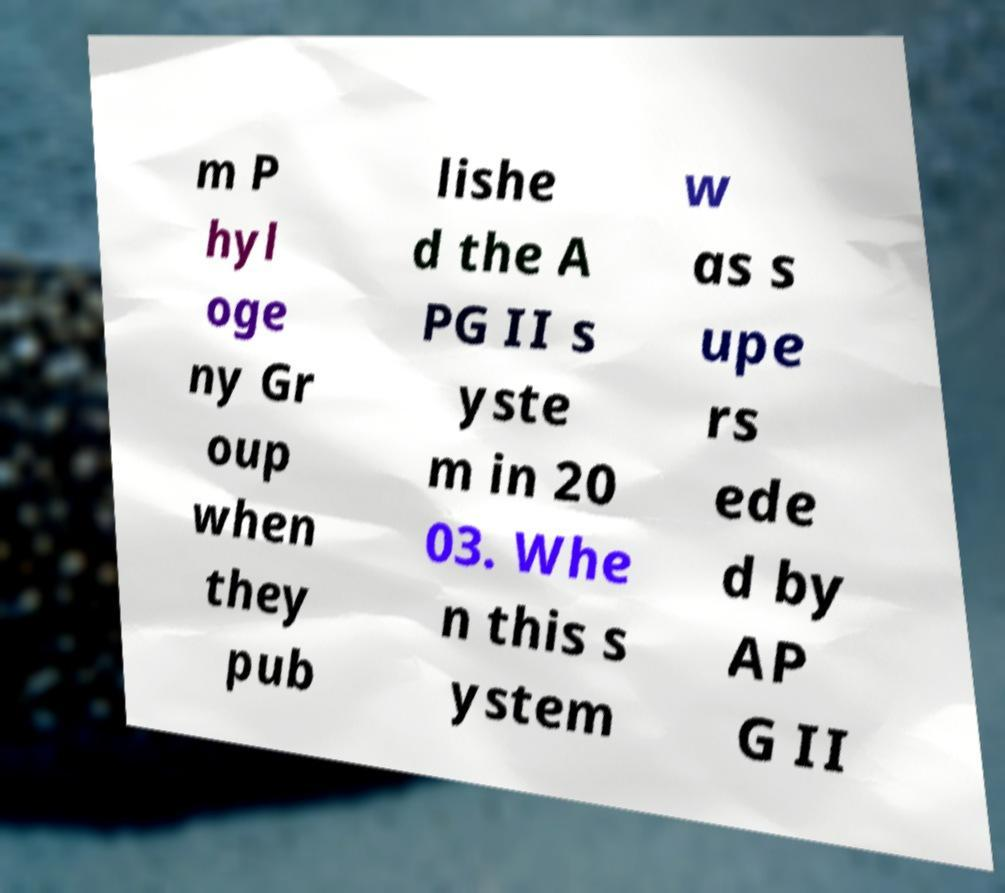Can you read and provide the text displayed in the image?This photo seems to have some interesting text. Can you extract and type it out for me? m P hyl oge ny Gr oup when they pub lishe d the A PG II s yste m in 20 03. Whe n this s ystem w as s upe rs ede d by AP G II 